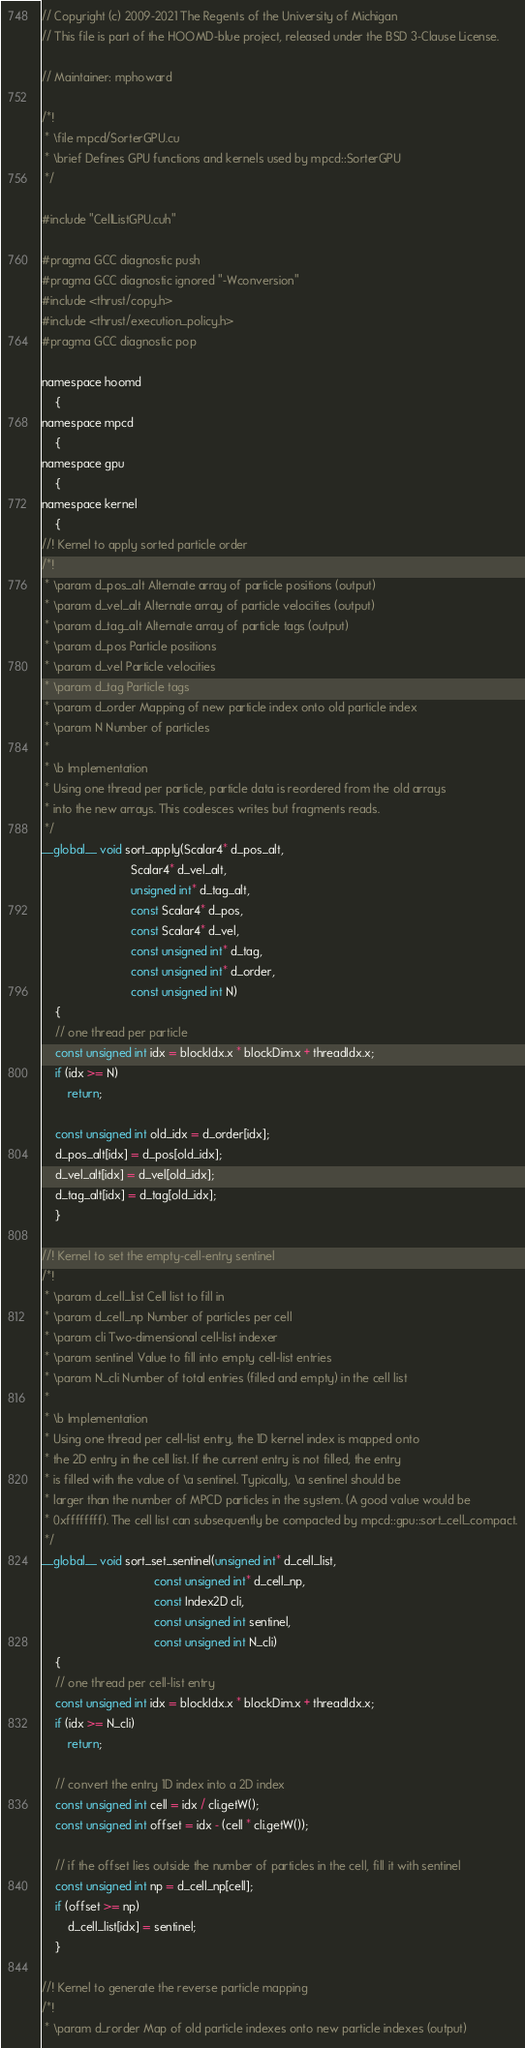Convert code to text. <code><loc_0><loc_0><loc_500><loc_500><_Cuda_>// Copyright (c) 2009-2021 The Regents of the University of Michigan
// This file is part of the HOOMD-blue project, released under the BSD 3-Clause License.

// Maintainer: mphoward

/*!
 * \file mpcd/SorterGPU.cu
 * \brief Defines GPU functions and kernels used by mpcd::SorterGPU
 */

#include "CellListGPU.cuh"

#pragma GCC diagnostic push
#pragma GCC diagnostic ignored "-Wconversion"
#include <thrust/copy.h>
#include <thrust/execution_policy.h>
#pragma GCC diagnostic pop

namespace hoomd
    {
namespace mpcd
    {
namespace gpu
    {
namespace kernel
    {
//! Kernel to apply sorted particle order
/*!
 * \param d_pos_alt Alternate array of particle positions (output)
 * \param d_vel_alt Alternate array of particle velocities (output)
 * \param d_tag_alt Alternate array of particle tags (output)
 * \param d_pos Particle positions
 * \param d_vel Particle velocities
 * \param d_tag Particle tags
 * \param d_order Mapping of new particle index onto old particle index
 * \param N Number of particles
 *
 * \b Implementation
 * Using one thread per particle, particle data is reordered from the old arrays
 * into the new arrays. This coalesces writes but fragments reads.
 */
__global__ void sort_apply(Scalar4* d_pos_alt,
                           Scalar4* d_vel_alt,
                           unsigned int* d_tag_alt,
                           const Scalar4* d_pos,
                           const Scalar4* d_vel,
                           const unsigned int* d_tag,
                           const unsigned int* d_order,
                           const unsigned int N)
    {
    // one thread per particle
    const unsigned int idx = blockIdx.x * blockDim.x + threadIdx.x;
    if (idx >= N)
        return;

    const unsigned int old_idx = d_order[idx];
    d_pos_alt[idx] = d_pos[old_idx];
    d_vel_alt[idx] = d_vel[old_idx];
    d_tag_alt[idx] = d_tag[old_idx];
    }

//! Kernel to set the empty-cell-entry sentinel
/*!
 * \param d_cell_list Cell list to fill in
 * \param d_cell_np Number of particles per cell
 * \param cli Two-dimensional cell-list indexer
 * \param sentinel Value to fill into empty cell-list entries
 * \param N_cli Number of total entries (filled and empty) in the cell list
 *
 * \b Implementation
 * Using one thread per cell-list entry, the 1D kernel index is mapped onto
 * the 2D entry in the cell list. If the current entry is not filled, the entry
 * is filled with the value of \a sentinel. Typically, \a sentinel should be
 * larger than the number of MPCD particles in the system. (A good value would be
 * 0xffffffff). The cell list can subsequently be compacted by mpcd::gpu::sort_cell_compact.
 */
__global__ void sort_set_sentinel(unsigned int* d_cell_list,
                                  const unsigned int* d_cell_np,
                                  const Index2D cli,
                                  const unsigned int sentinel,
                                  const unsigned int N_cli)
    {
    // one thread per cell-list entry
    const unsigned int idx = blockIdx.x * blockDim.x + threadIdx.x;
    if (idx >= N_cli)
        return;

    // convert the entry 1D index into a 2D index
    const unsigned int cell = idx / cli.getW();
    const unsigned int offset = idx - (cell * cli.getW());

    // if the offset lies outside the number of particles in the cell, fill it with sentinel
    const unsigned int np = d_cell_np[cell];
    if (offset >= np)
        d_cell_list[idx] = sentinel;
    }

//! Kernel to generate the reverse particle mapping
/*!
 * \param d_rorder Map of old particle indexes onto new particle indexes (output)</code> 